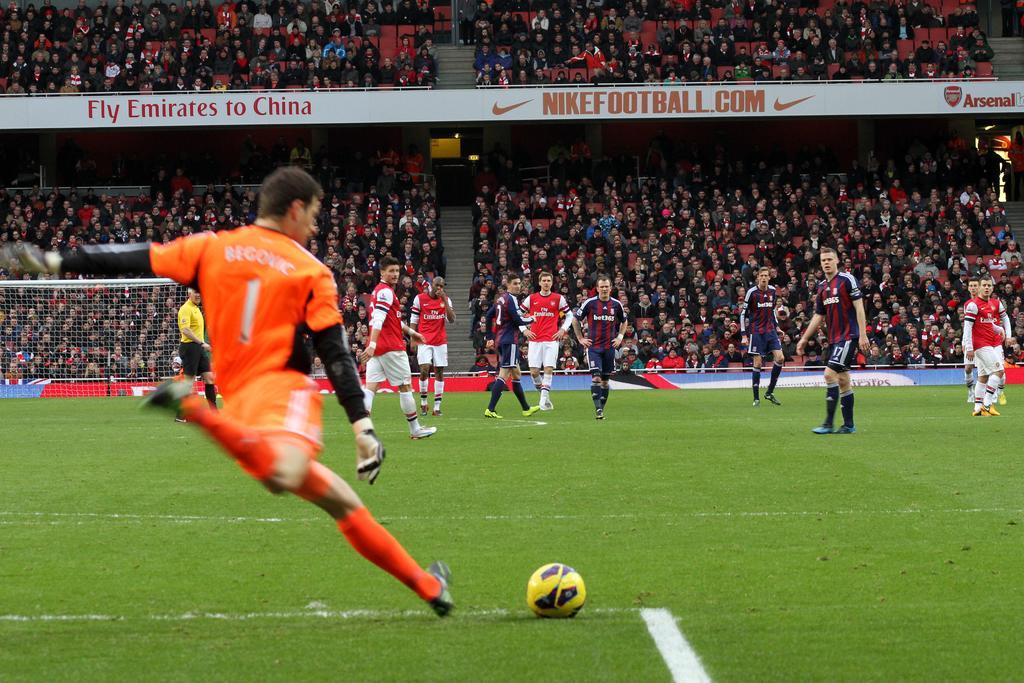Could you give a brief overview of what you see in this image? In this picture I can see a stadium, where there are group of people playing a game with a ball, there is a football net, and in the background there are group of people, chairs, stairs, iron rods and boards. 